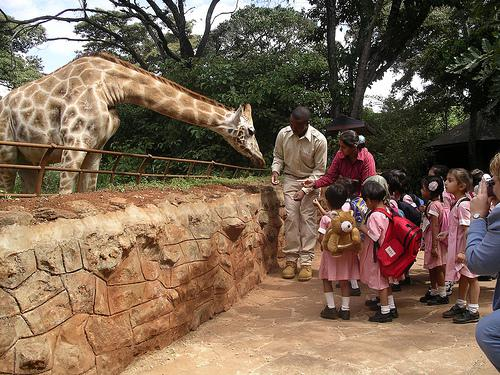Question: who is the man in beige shirt?
Choices:
A. The zookeeper.
B. The teacher.
C. The minister.
D. The animal keeper.
Answer with the letter. Answer: A Question: what animal is behind the fence?
Choices:
A. A zebra.
B. An elephant.
C. A wildebeast.
D. A giraffe.
Answer with the letter. Answer: D Question: why the giraffe is behind the fence?
Choices:
A. So it will be safe.
B. So other animals won't get in.
C. So it won't wander.
D. For fun.
Answer with the letter. Answer: C Question: how many giraffes in the fence?
Choices:
A. Two.
B. Zero.
C. One.
D. Three.
Answer with the letter. Answer: C 